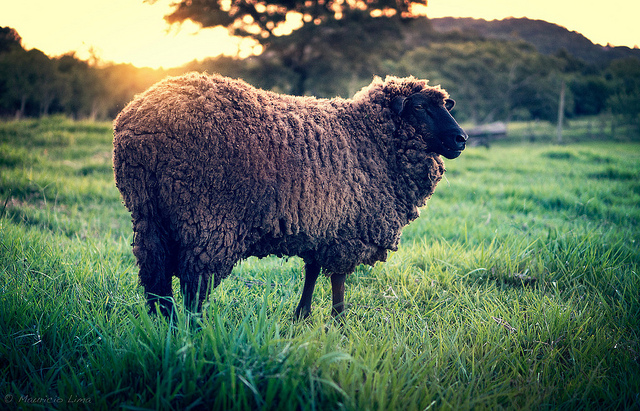What can you tell me about the breed of this sheep and its wool quality? While identifying the exact breed can be challenging from the image alone, the sheep has a thick, curly coat which suggests it might be a breed known for wool production. Breeds with dense and curly wool, such as Merino, Romney, or Lincoln, are often highly valued for their fleece. The quality and volume of the wool on this sheep indicate it could produce high-quality wool for various products. 